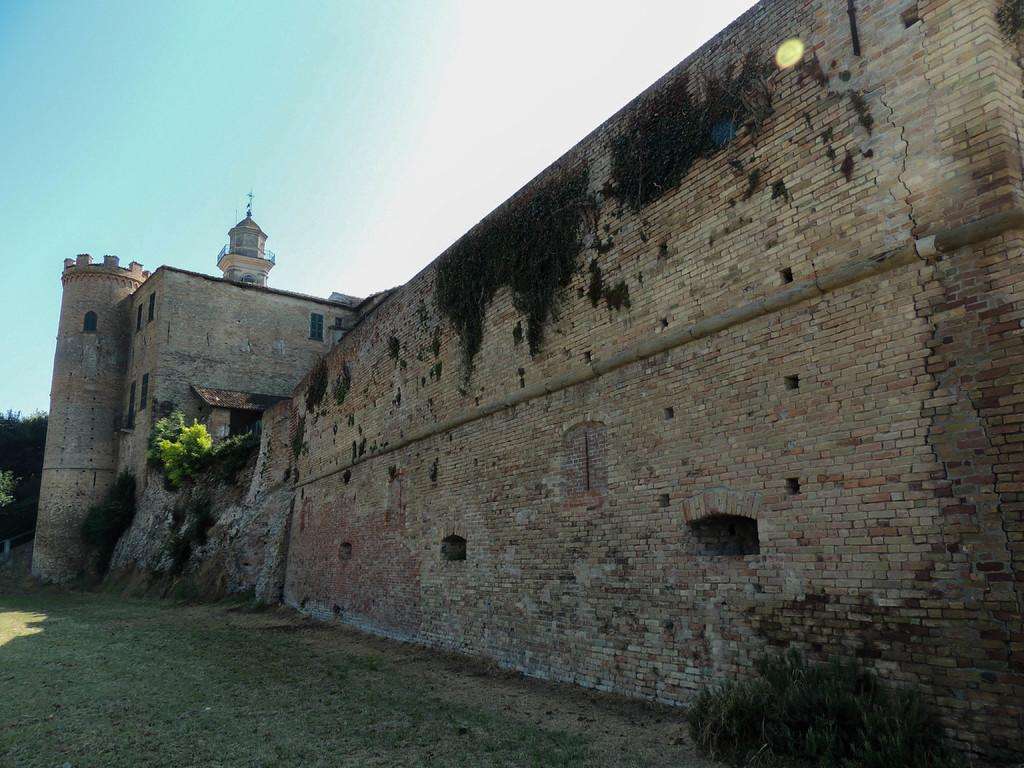What is the main structure in the center of the image? There is a wall in the center of the image. What can be seen on the left side of the image? There is a building on the left side of the image. What type of natural environment is visible in the bottom left side of the image? There is grassland in the bottom left side of the image. How much salt is present on the wall in the image? There is no salt present on the wall in the image. What part of the brain can be seen in the image? There is no brain present in the image; it features a wall and a building. 